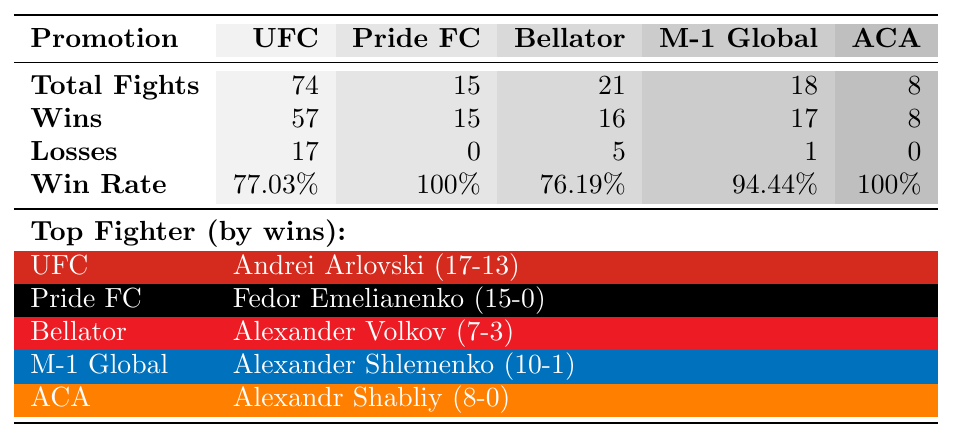What promotion has the highest total fights? Looking at the total fights row, UFC has 74 total fights, which is more than any other promotion listed (Pride FC has 15, Bellator has 21, M-1 Global has 18, and ACA has 8).
Answer: UFC Which promotion has a 100% win rate? The win rate row shows that Pride FC and ACA both have a 100% win rate. This means all fighters in these promotions have won all their matches without any losses.
Answer: Yes, Pride FC and ACA How many losses did UFC fighters have in total? From the losses row, UFC fighters collectively have 17 losses. This total can be directly read from the table without any calculation.
Answer: 17 What is the average win rate of the fighters in Bellator? To find the average win rate for Bellator, we use the win rate value listed for Bellator, which is 76.19%. Since there's only one entry, the average is just this single value.
Answer: 76.19% Who is the top fighter in M-1 Global and what is their win-loss record? The table shows that the top fighter in M-1 Global is Alexander Shlemenko, with a record of 10 wins and 1 loss. This information is derived from the top fighter row for M-1 Global.
Answer: Alexander Shlemenko (10-1) How many more wins do UFC fighters have compared to Bellator fighters? UFC fighters have 57 wins, while Bellator fighters have 16 wins. Therefore, the difference in wins is calculated as 57 (UFC) - 16 (Bellator) = 41 wins.
Answer: 41 What percentage of fighters in M-1 Global are undefeated? The losses row shows that M-1 Global has only 1 loss total and one fighter, Alexander Shlemenko, with 1 loss. Since there are 18 total fights, the only loss means the percentage of unbeaten fighters is (17/18)*100 = 94.44%.
Answer: 94.44% Is there any fighter in ACA with a record below 500? Based on the table, Alexandr Shabliy is the only identified fighter in ACA and has a perfect record of 8-0. Therefore, there are no fighters in ACA with a losing record.
Answer: No 